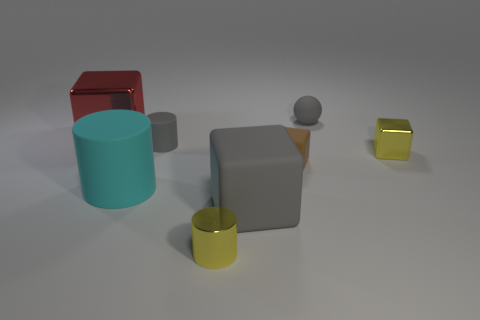Can you describe the lighting in the scene? The lighting in the scene is soft and diffused, likely coming from an overhead source. The shadows are soft-edged and there is no harsh direct light, which contributes to the calm and clear atmosphere of the image. Does the lighting reveal anything about the shape of the objects? Yes, the gentle shadows help accentuate the three-dimensionality of the objects, highlighting their geometric shapes and the subtle reflections indicate the curvature on the surfaces of the cylinders and the sphere. 